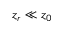<formula> <loc_0><loc_0><loc_500><loc_500>z _ { r } \ll z _ { 0 }</formula> 